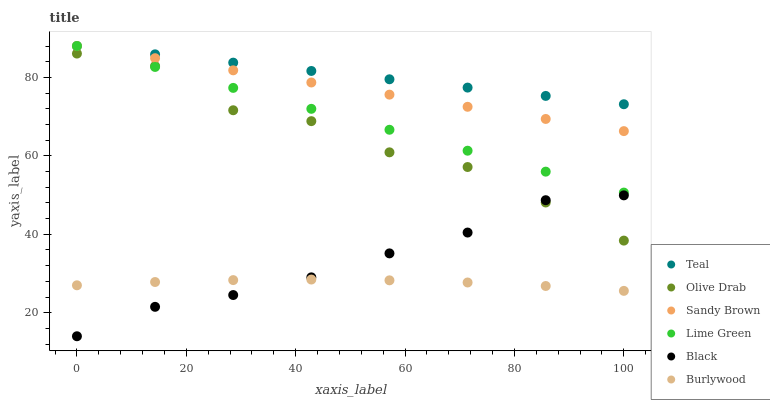Does Burlywood have the minimum area under the curve?
Answer yes or no. Yes. Does Teal have the maximum area under the curve?
Answer yes or no. Yes. Does Sandy Brown have the minimum area under the curve?
Answer yes or no. No. Does Sandy Brown have the maximum area under the curve?
Answer yes or no. No. Is Sandy Brown the smoothest?
Answer yes or no. Yes. Is Olive Drab the roughest?
Answer yes or no. Yes. Is Black the smoothest?
Answer yes or no. No. Is Black the roughest?
Answer yes or no. No. Does Black have the lowest value?
Answer yes or no. Yes. Does Sandy Brown have the lowest value?
Answer yes or no. No. Does Lime Green have the highest value?
Answer yes or no. Yes. Does Black have the highest value?
Answer yes or no. No. Is Black less than Teal?
Answer yes or no. Yes. Is Sandy Brown greater than Black?
Answer yes or no. Yes. Does Black intersect Burlywood?
Answer yes or no. Yes. Is Black less than Burlywood?
Answer yes or no. No. Is Black greater than Burlywood?
Answer yes or no. No. Does Black intersect Teal?
Answer yes or no. No. 